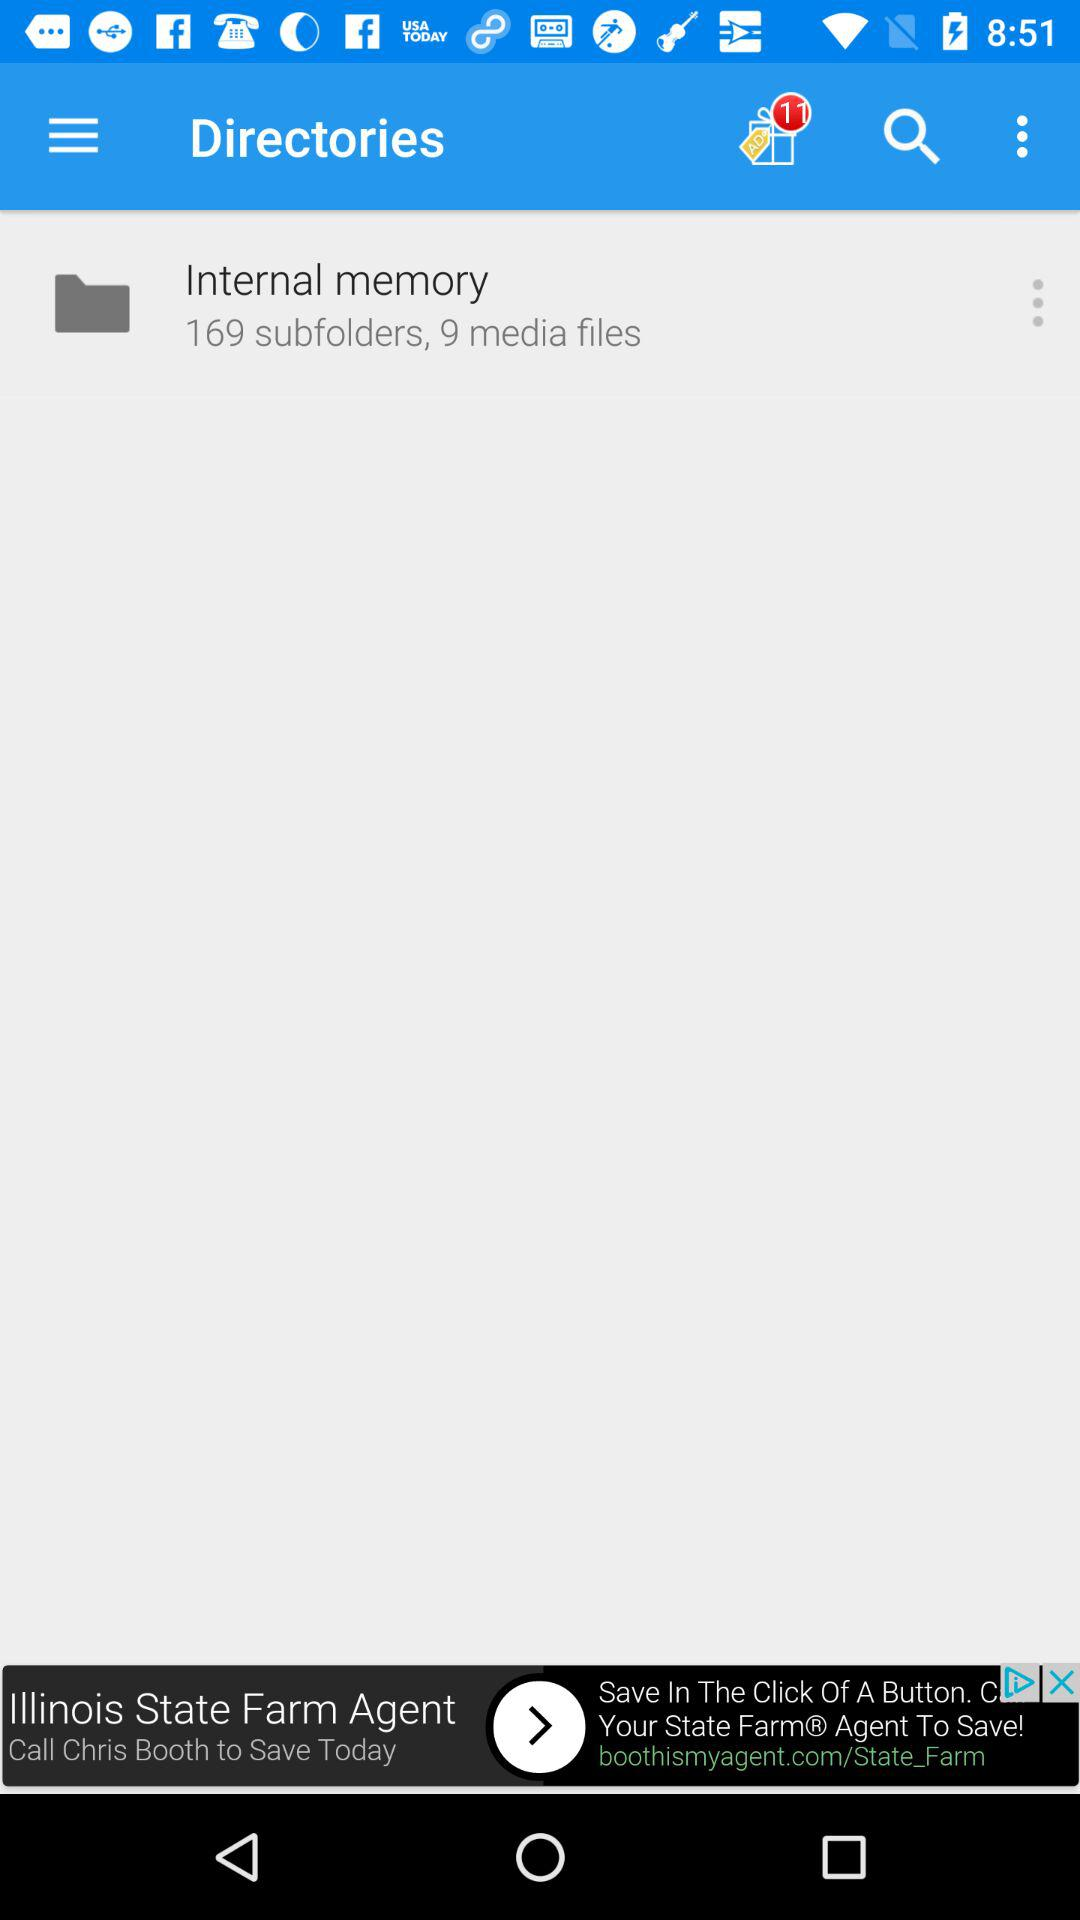How many media files are in the "Internal Memory"? There are 9 media files. 